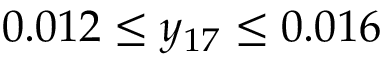<formula> <loc_0><loc_0><loc_500><loc_500>0 . 0 1 2 \leq y _ { 1 7 } \leq 0 . 0 1 6</formula> 